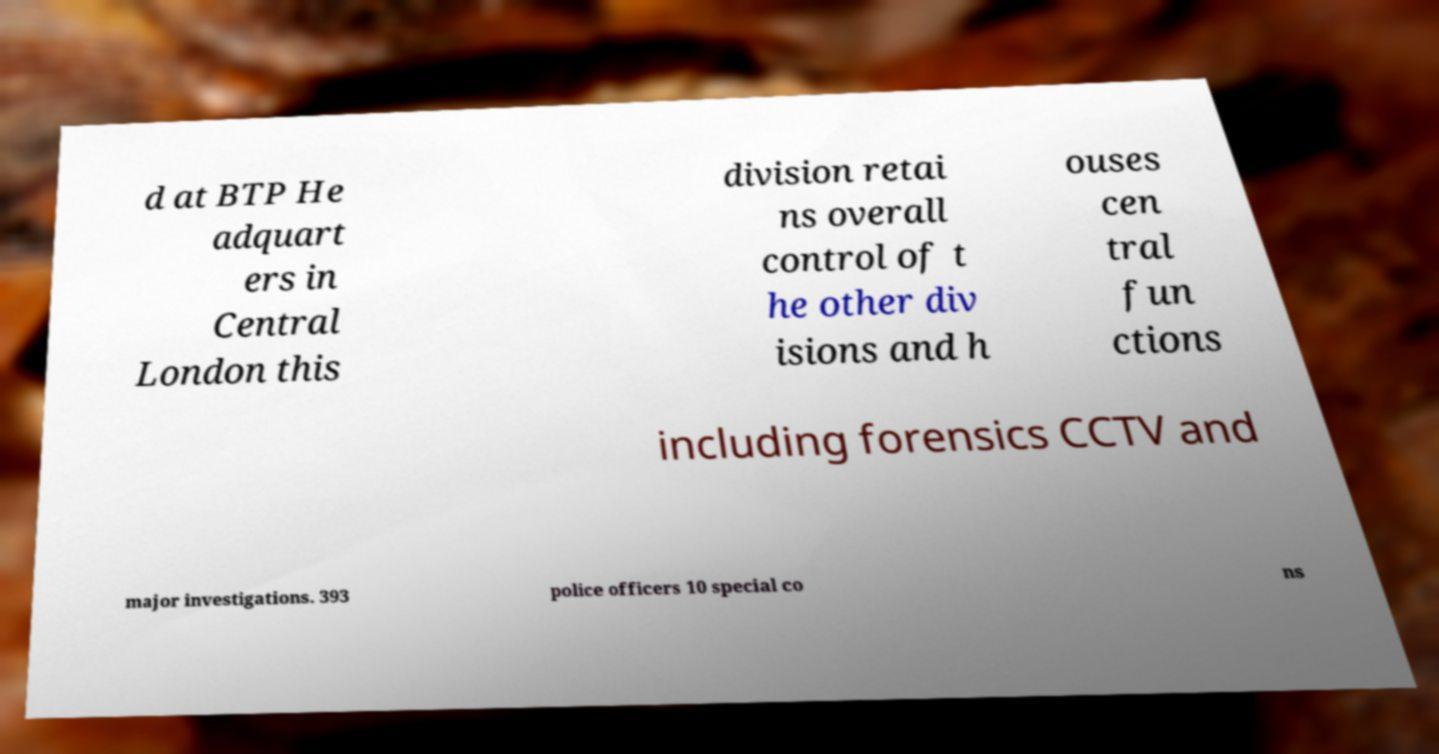Can you read and provide the text displayed in the image?This photo seems to have some interesting text. Can you extract and type it out for me? d at BTP He adquart ers in Central London this division retai ns overall control of t he other div isions and h ouses cen tral fun ctions including forensics CCTV and major investigations. 393 police officers 10 special co ns 